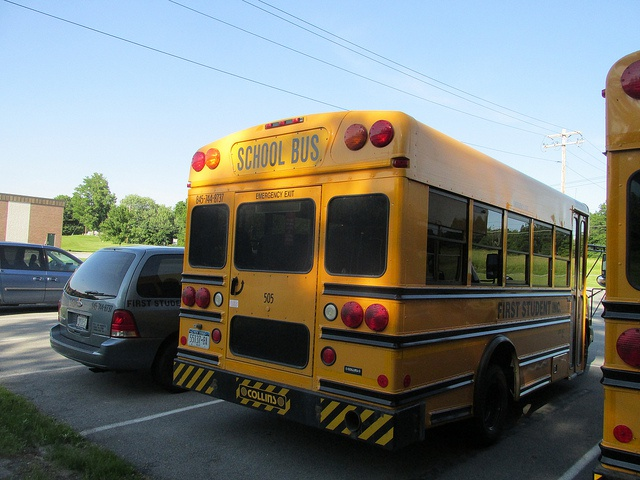Describe the objects in this image and their specific colors. I can see bus in lightblue, black, olive, and maroon tones, bus in lightblue, olive, black, and gray tones, car in lightblue, black, gray, and blue tones, and car in lightblue, gray, black, and blue tones in this image. 